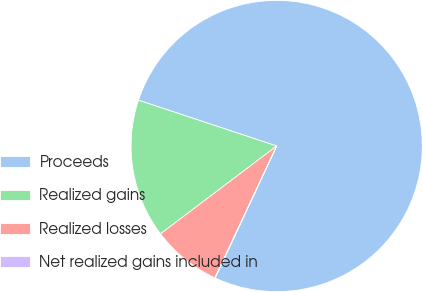<chart> <loc_0><loc_0><loc_500><loc_500><pie_chart><fcel>Proceeds<fcel>Realized gains<fcel>Realized losses<fcel>Net realized gains included in<nl><fcel>76.84%<fcel>15.4%<fcel>7.72%<fcel>0.04%<nl></chart> 